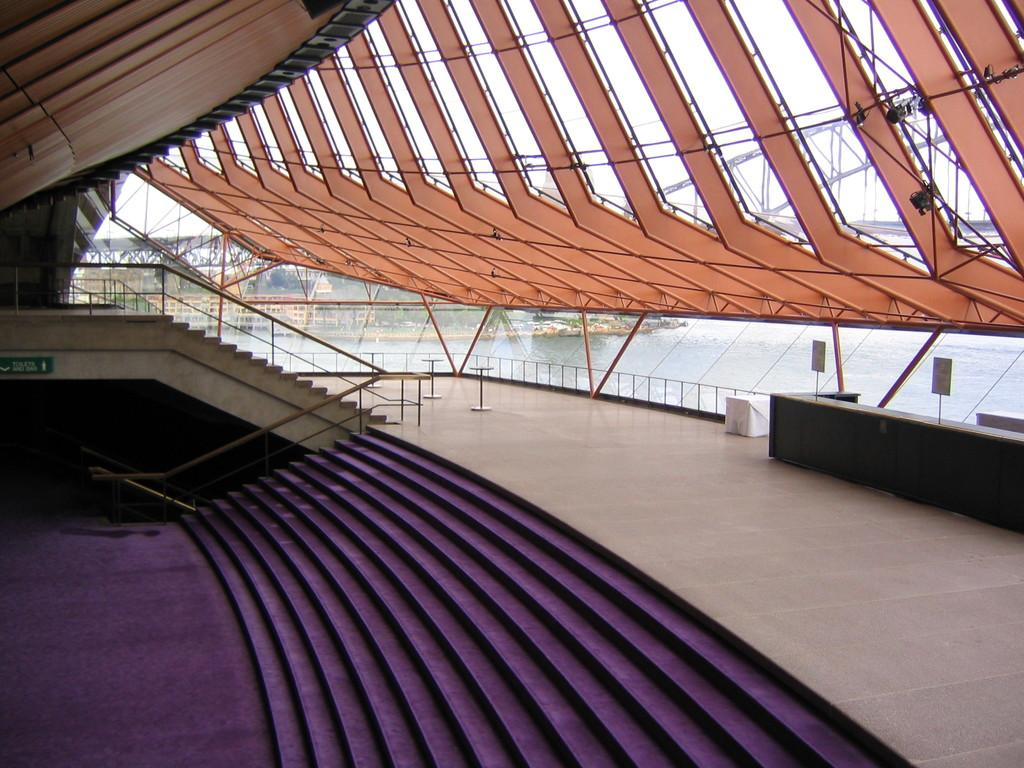Where was the image taken? The image was clicked outside. What can be seen in the image? The image appears to show a stadium. What architectural feature is visible at the bottom of the image? There are steps at the bottom of the image. What is present at the top of the image? There is a roof at the top of the image. What natural element is visible to the right of the image? There is water visible to the right of the image. Can you see a thumbprint on the roof of the stadium in the image? There is no thumbprint visible on the roof of the stadium in the image. Is there a girl committing a crime in the image? There is no girl or crime present in the image; it shows a stadium with steps, a roof, and water visible to the right. 